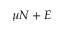Convert formula to latex. <formula><loc_0><loc_0><loc_500><loc_500>\mu N + E</formula> 